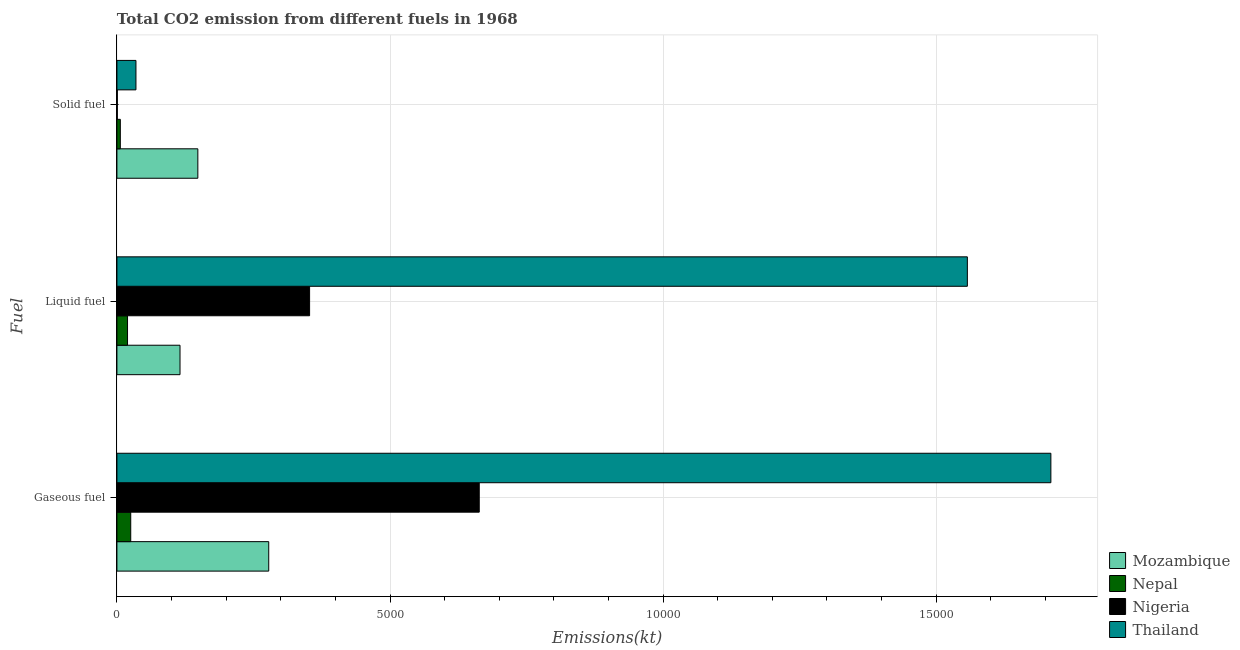Are the number of bars per tick equal to the number of legend labels?
Your answer should be compact. Yes. Are the number of bars on each tick of the Y-axis equal?
Offer a terse response. Yes. How many bars are there on the 2nd tick from the top?
Offer a very short reply. 4. What is the label of the 1st group of bars from the top?
Ensure brevity in your answer.  Solid fuel. What is the amount of co2 emissions from solid fuel in Nigeria?
Your answer should be compact. 7.33. Across all countries, what is the maximum amount of co2 emissions from solid fuel?
Your response must be concise. 1481.47. Across all countries, what is the minimum amount of co2 emissions from liquid fuel?
Give a very brief answer. 194.35. In which country was the amount of co2 emissions from liquid fuel maximum?
Ensure brevity in your answer.  Thailand. In which country was the amount of co2 emissions from liquid fuel minimum?
Your answer should be very brief. Nepal. What is the total amount of co2 emissions from liquid fuel in the graph?
Keep it short and to the point. 2.04e+04. What is the difference between the amount of co2 emissions from solid fuel in Nigeria and that in Nepal?
Your response must be concise. -55. What is the difference between the amount of co2 emissions from gaseous fuel in Thailand and the amount of co2 emissions from liquid fuel in Mozambique?
Make the answer very short. 1.59e+04. What is the average amount of co2 emissions from solid fuel per country?
Ensure brevity in your answer.  474.88. What is the difference between the amount of co2 emissions from solid fuel and amount of co2 emissions from liquid fuel in Mozambique?
Offer a terse response. 326.36. In how many countries, is the amount of co2 emissions from solid fuel greater than 16000 kt?
Make the answer very short. 0. What is the ratio of the amount of co2 emissions from gaseous fuel in Thailand to that in Nepal?
Ensure brevity in your answer.  67.58. Is the difference between the amount of co2 emissions from solid fuel in Thailand and Nepal greater than the difference between the amount of co2 emissions from liquid fuel in Thailand and Nepal?
Provide a succinct answer. No. What is the difference between the highest and the second highest amount of co2 emissions from solid fuel?
Your response must be concise. 1133.1. What is the difference between the highest and the lowest amount of co2 emissions from solid fuel?
Offer a terse response. 1474.13. What does the 2nd bar from the top in Gaseous fuel represents?
Make the answer very short. Nigeria. What does the 2nd bar from the bottom in Gaseous fuel represents?
Your response must be concise. Nepal. How many countries are there in the graph?
Your response must be concise. 4. Does the graph contain any zero values?
Provide a short and direct response. No. Where does the legend appear in the graph?
Provide a succinct answer. Bottom right. What is the title of the graph?
Offer a terse response. Total CO2 emission from different fuels in 1968. What is the label or title of the X-axis?
Offer a terse response. Emissions(kt). What is the label or title of the Y-axis?
Provide a short and direct response. Fuel. What is the Emissions(kt) in Mozambique in Gaseous fuel?
Your answer should be compact. 2779.59. What is the Emissions(kt) in Nepal in Gaseous fuel?
Make the answer very short. 253.02. What is the Emissions(kt) of Nigeria in Gaseous fuel?
Give a very brief answer. 6633.6. What is the Emissions(kt) of Thailand in Gaseous fuel?
Give a very brief answer. 1.71e+04. What is the Emissions(kt) of Mozambique in Liquid fuel?
Keep it short and to the point. 1155.11. What is the Emissions(kt) in Nepal in Liquid fuel?
Provide a succinct answer. 194.35. What is the Emissions(kt) in Nigeria in Liquid fuel?
Ensure brevity in your answer.  3527.65. What is the Emissions(kt) of Thailand in Liquid fuel?
Provide a succinct answer. 1.56e+04. What is the Emissions(kt) of Mozambique in Solid fuel?
Provide a succinct answer. 1481.47. What is the Emissions(kt) in Nepal in Solid fuel?
Make the answer very short. 62.34. What is the Emissions(kt) in Nigeria in Solid fuel?
Keep it short and to the point. 7.33. What is the Emissions(kt) of Thailand in Solid fuel?
Provide a short and direct response. 348.37. Across all Fuel, what is the maximum Emissions(kt) in Mozambique?
Offer a terse response. 2779.59. Across all Fuel, what is the maximum Emissions(kt) in Nepal?
Your answer should be very brief. 253.02. Across all Fuel, what is the maximum Emissions(kt) in Nigeria?
Give a very brief answer. 6633.6. Across all Fuel, what is the maximum Emissions(kt) of Thailand?
Your answer should be very brief. 1.71e+04. Across all Fuel, what is the minimum Emissions(kt) of Mozambique?
Provide a short and direct response. 1155.11. Across all Fuel, what is the minimum Emissions(kt) in Nepal?
Ensure brevity in your answer.  62.34. Across all Fuel, what is the minimum Emissions(kt) in Nigeria?
Offer a very short reply. 7.33. Across all Fuel, what is the minimum Emissions(kt) in Thailand?
Ensure brevity in your answer.  348.37. What is the total Emissions(kt) in Mozambique in the graph?
Make the answer very short. 5416.16. What is the total Emissions(kt) of Nepal in the graph?
Provide a short and direct response. 509.71. What is the total Emissions(kt) in Nigeria in the graph?
Give a very brief answer. 1.02e+04. What is the total Emissions(kt) in Thailand in the graph?
Offer a very short reply. 3.30e+04. What is the difference between the Emissions(kt) of Mozambique in Gaseous fuel and that in Liquid fuel?
Offer a very short reply. 1624.48. What is the difference between the Emissions(kt) of Nepal in Gaseous fuel and that in Liquid fuel?
Offer a terse response. 58.67. What is the difference between the Emissions(kt) of Nigeria in Gaseous fuel and that in Liquid fuel?
Give a very brief answer. 3105.95. What is the difference between the Emissions(kt) of Thailand in Gaseous fuel and that in Liquid fuel?
Give a very brief answer. 1529.14. What is the difference between the Emissions(kt) of Mozambique in Gaseous fuel and that in Solid fuel?
Offer a very short reply. 1298.12. What is the difference between the Emissions(kt) of Nepal in Gaseous fuel and that in Solid fuel?
Offer a very short reply. 190.68. What is the difference between the Emissions(kt) of Nigeria in Gaseous fuel and that in Solid fuel?
Offer a terse response. 6626.27. What is the difference between the Emissions(kt) in Thailand in Gaseous fuel and that in Solid fuel?
Your answer should be compact. 1.68e+04. What is the difference between the Emissions(kt) in Mozambique in Liquid fuel and that in Solid fuel?
Offer a terse response. -326.36. What is the difference between the Emissions(kt) in Nepal in Liquid fuel and that in Solid fuel?
Your answer should be very brief. 132.01. What is the difference between the Emissions(kt) of Nigeria in Liquid fuel and that in Solid fuel?
Your response must be concise. 3520.32. What is the difference between the Emissions(kt) in Thailand in Liquid fuel and that in Solid fuel?
Offer a very short reply. 1.52e+04. What is the difference between the Emissions(kt) in Mozambique in Gaseous fuel and the Emissions(kt) in Nepal in Liquid fuel?
Provide a short and direct response. 2585.24. What is the difference between the Emissions(kt) of Mozambique in Gaseous fuel and the Emissions(kt) of Nigeria in Liquid fuel?
Offer a terse response. -748.07. What is the difference between the Emissions(kt) in Mozambique in Gaseous fuel and the Emissions(kt) in Thailand in Liquid fuel?
Give a very brief answer. -1.28e+04. What is the difference between the Emissions(kt) of Nepal in Gaseous fuel and the Emissions(kt) of Nigeria in Liquid fuel?
Your response must be concise. -3274.63. What is the difference between the Emissions(kt) in Nepal in Gaseous fuel and the Emissions(kt) in Thailand in Liquid fuel?
Your response must be concise. -1.53e+04. What is the difference between the Emissions(kt) of Nigeria in Gaseous fuel and the Emissions(kt) of Thailand in Liquid fuel?
Ensure brevity in your answer.  -8936.48. What is the difference between the Emissions(kt) in Mozambique in Gaseous fuel and the Emissions(kt) in Nepal in Solid fuel?
Provide a succinct answer. 2717.25. What is the difference between the Emissions(kt) in Mozambique in Gaseous fuel and the Emissions(kt) in Nigeria in Solid fuel?
Provide a short and direct response. 2772.25. What is the difference between the Emissions(kt) in Mozambique in Gaseous fuel and the Emissions(kt) in Thailand in Solid fuel?
Your response must be concise. 2431.22. What is the difference between the Emissions(kt) of Nepal in Gaseous fuel and the Emissions(kt) of Nigeria in Solid fuel?
Provide a succinct answer. 245.69. What is the difference between the Emissions(kt) in Nepal in Gaseous fuel and the Emissions(kt) in Thailand in Solid fuel?
Make the answer very short. -95.34. What is the difference between the Emissions(kt) in Nigeria in Gaseous fuel and the Emissions(kt) in Thailand in Solid fuel?
Your answer should be compact. 6285.24. What is the difference between the Emissions(kt) of Mozambique in Liquid fuel and the Emissions(kt) of Nepal in Solid fuel?
Offer a very short reply. 1092.77. What is the difference between the Emissions(kt) of Mozambique in Liquid fuel and the Emissions(kt) of Nigeria in Solid fuel?
Your answer should be very brief. 1147.77. What is the difference between the Emissions(kt) of Mozambique in Liquid fuel and the Emissions(kt) of Thailand in Solid fuel?
Give a very brief answer. 806.74. What is the difference between the Emissions(kt) in Nepal in Liquid fuel and the Emissions(kt) in Nigeria in Solid fuel?
Provide a succinct answer. 187.02. What is the difference between the Emissions(kt) of Nepal in Liquid fuel and the Emissions(kt) of Thailand in Solid fuel?
Your answer should be very brief. -154.01. What is the difference between the Emissions(kt) in Nigeria in Liquid fuel and the Emissions(kt) in Thailand in Solid fuel?
Provide a succinct answer. 3179.29. What is the average Emissions(kt) of Mozambique per Fuel?
Keep it short and to the point. 1805.39. What is the average Emissions(kt) of Nepal per Fuel?
Your response must be concise. 169.9. What is the average Emissions(kt) in Nigeria per Fuel?
Give a very brief answer. 3389.53. What is the average Emissions(kt) of Thailand per Fuel?
Offer a terse response. 1.10e+04. What is the difference between the Emissions(kt) of Mozambique and Emissions(kt) of Nepal in Gaseous fuel?
Provide a succinct answer. 2526.56. What is the difference between the Emissions(kt) in Mozambique and Emissions(kt) in Nigeria in Gaseous fuel?
Give a very brief answer. -3854.02. What is the difference between the Emissions(kt) in Mozambique and Emissions(kt) in Thailand in Gaseous fuel?
Your response must be concise. -1.43e+04. What is the difference between the Emissions(kt) of Nepal and Emissions(kt) of Nigeria in Gaseous fuel?
Offer a very short reply. -6380.58. What is the difference between the Emissions(kt) in Nepal and Emissions(kt) in Thailand in Gaseous fuel?
Your answer should be very brief. -1.68e+04. What is the difference between the Emissions(kt) in Nigeria and Emissions(kt) in Thailand in Gaseous fuel?
Keep it short and to the point. -1.05e+04. What is the difference between the Emissions(kt) in Mozambique and Emissions(kt) in Nepal in Liquid fuel?
Ensure brevity in your answer.  960.75. What is the difference between the Emissions(kt) in Mozambique and Emissions(kt) in Nigeria in Liquid fuel?
Make the answer very short. -2372.55. What is the difference between the Emissions(kt) of Mozambique and Emissions(kt) of Thailand in Liquid fuel?
Provide a succinct answer. -1.44e+04. What is the difference between the Emissions(kt) in Nepal and Emissions(kt) in Nigeria in Liquid fuel?
Ensure brevity in your answer.  -3333.3. What is the difference between the Emissions(kt) in Nepal and Emissions(kt) in Thailand in Liquid fuel?
Provide a succinct answer. -1.54e+04. What is the difference between the Emissions(kt) in Nigeria and Emissions(kt) in Thailand in Liquid fuel?
Provide a succinct answer. -1.20e+04. What is the difference between the Emissions(kt) in Mozambique and Emissions(kt) in Nepal in Solid fuel?
Offer a terse response. 1419.13. What is the difference between the Emissions(kt) of Mozambique and Emissions(kt) of Nigeria in Solid fuel?
Your answer should be compact. 1474.13. What is the difference between the Emissions(kt) of Mozambique and Emissions(kt) of Thailand in Solid fuel?
Ensure brevity in your answer.  1133.1. What is the difference between the Emissions(kt) in Nepal and Emissions(kt) in Nigeria in Solid fuel?
Your answer should be compact. 55.01. What is the difference between the Emissions(kt) of Nepal and Emissions(kt) of Thailand in Solid fuel?
Offer a terse response. -286.03. What is the difference between the Emissions(kt) in Nigeria and Emissions(kt) in Thailand in Solid fuel?
Your answer should be compact. -341.03. What is the ratio of the Emissions(kt) in Mozambique in Gaseous fuel to that in Liquid fuel?
Give a very brief answer. 2.41. What is the ratio of the Emissions(kt) in Nepal in Gaseous fuel to that in Liquid fuel?
Keep it short and to the point. 1.3. What is the ratio of the Emissions(kt) of Nigeria in Gaseous fuel to that in Liquid fuel?
Offer a very short reply. 1.88. What is the ratio of the Emissions(kt) in Thailand in Gaseous fuel to that in Liquid fuel?
Give a very brief answer. 1.1. What is the ratio of the Emissions(kt) of Mozambique in Gaseous fuel to that in Solid fuel?
Your answer should be compact. 1.88. What is the ratio of the Emissions(kt) in Nepal in Gaseous fuel to that in Solid fuel?
Keep it short and to the point. 4.06. What is the ratio of the Emissions(kt) of Nigeria in Gaseous fuel to that in Solid fuel?
Provide a succinct answer. 904.5. What is the ratio of the Emissions(kt) of Thailand in Gaseous fuel to that in Solid fuel?
Your response must be concise. 49.08. What is the ratio of the Emissions(kt) of Mozambique in Liquid fuel to that in Solid fuel?
Ensure brevity in your answer.  0.78. What is the ratio of the Emissions(kt) in Nepal in Liquid fuel to that in Solid fuel?
Give a very brief answer. 3.12. What is the ratio of the Emissions(kt) in Nigeria in Liquid fuel to that in Solid fuel?
Provide a short and direct response. 481. What is the ratio of the Emissions(kt) of Thailand in Liquid fuel to that in Solid fuel?
Provide a succinct answer. 44.69. What is the difference between the highest and the second highest Emissions(kt) in Mozambique?
Your response must be concise. 1298.12. What is the difference between the highest and the second highest Emissions(kt) of Nepal?
Give a very brief answer. 58.67. What is the difference between the highest and the second highest Emissions(kt) of Nigeria?
Keep it short and to the point. 3105.95. What is the difference between the highest and the second highest Emissions(kt) in Thailand?
Give a very brief answer. 1529.14. What is the difference between the highest and the lowest Emissions(kt) of Mozambique?
Give a very brief answer. 1624.48. What is the difference between the highest and the lowest Emissions(kt) in Nepal?
Offer a very short reply. 190.68. What is the difference between the highest and the lowest Emissions(kt) of Nigeria?
Give a very brief answer. 6626.27. What is the difference between the highest and the lowest Emissions(kt) in Thailand?
Keep it short and to the point. 1.68e+04. 